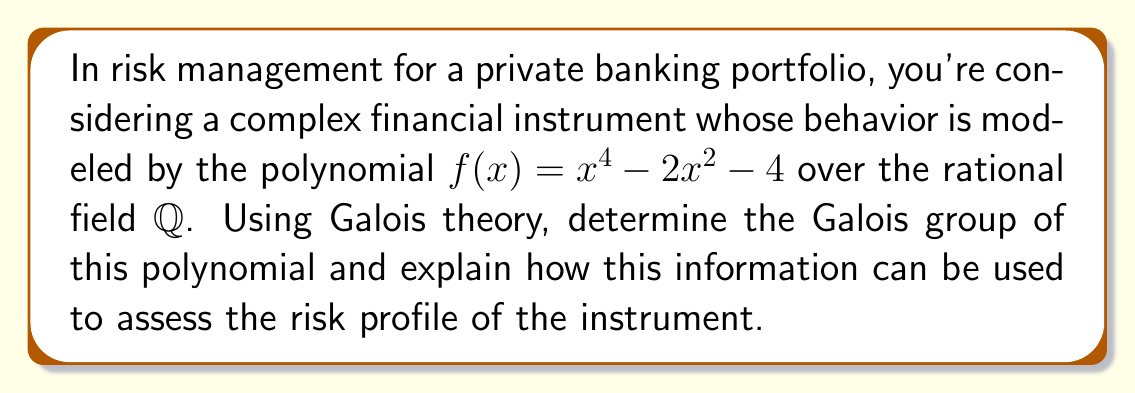Provide a solution to this math problem. 1. First, we need to find the splitting field of $f(x)$ over $\mathbb{Q}$.

2. Factor $f(x)$:
   $f(x) = x^4 - 2x^2 - 4 = (x^2 - 2)^2 - 8 = (x^2 - 2 - 2\sqrt{2})(x^2 - 2 + 2\sqrt{2})$

3. The roots of $f(x)$ are:
   $\pm\sqrt{2 + 2\sqrt{2}}$ and $\pm\sqrt{2 - 2\sqrt{2}}$

4. The splitting field is $\mathbb{Q}(\sqrt{2}, \sqrt{2 + 2\sqrt{2}})$.

5. To find the Galois group, we need to determine the automorphisms of this field that fix $\mathbb{Q}$.

6. There are four such automorphisms:
   - Identity: $\sigma_1(\sqrt{2}) = \sqrt{2}, \sigma_1(\sqrt{2 + 2\sqrt{2}}) = \sqrt{2 + 2\sqrt{2}}$
   - $\sigma_2(\sqrt{2}) = \sqrt{2}, \sigma_2(\sqrt{2 + 2\sqrt{2}}) = -\sqrt{2 + 2\sqrt{2}}$
   - $\sigma_3(\sqrt{2}) = -\sqrt{2}, \sigma_3(\sqrt{2 + 2\sqrt{2}}) = \sqrt{2 - 2\sqrt{2}}$
   - $\sigma_4(\sqrt{2}) = -\sqrt{2}, \sigma_4(\sqrt{2 + 2\sqrt{2}}) = -\sqrt{2 - 2\sqrt{2}}$

7. These automorphisms form a group isomorphic to the Klein four-group $V_4$.

8. In terms of risk management:
   - The Galois group structure reveals symmetries in the possible states of the financial instrument.
   - $V_4$ being abelian implies that the instrument's behavior has certain predictable patterns.
   - The small size of the group (order 4) suggests limited complexity in possible outcomes.
   - Each automorphism represents a potential scenario for the instrument's performance, allowing for comprehensive risk analysis.
Answer: Galois group is $V_4$; implies symmetrical, partially predictable behavior with limited complexity. 